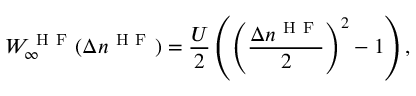Convert formula to latex. <formula><loc_0><loc_0><loc_500><loc_500>W _ { \infty } ^ { H F } ( \Delta n ^ { H F } ) = \frac { U } { 2 } \left ( \left ( \frac { \Delta n ^ { H F } } { 2 } \right ) ^ { 2 } - 1 \right ) ,</formula> 